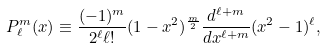Convert formula to latex. <formula><loc_0><loc_0><loc_500><loc_500>P ^ { m } _ { \ell } ( x ) \equiv \frac { ( - 1 ) ^ { m } } { 2 ^ { \ell } \ell ! } ( 1 - x ^ { 2 } ) ^ { \frac { m } { 2 } } \frac { d ^ { \ell + m } } { d x ^ { \ell + m } } ( x ^ { 2 } - 1 ) ^ { \ell } ,</formula> 